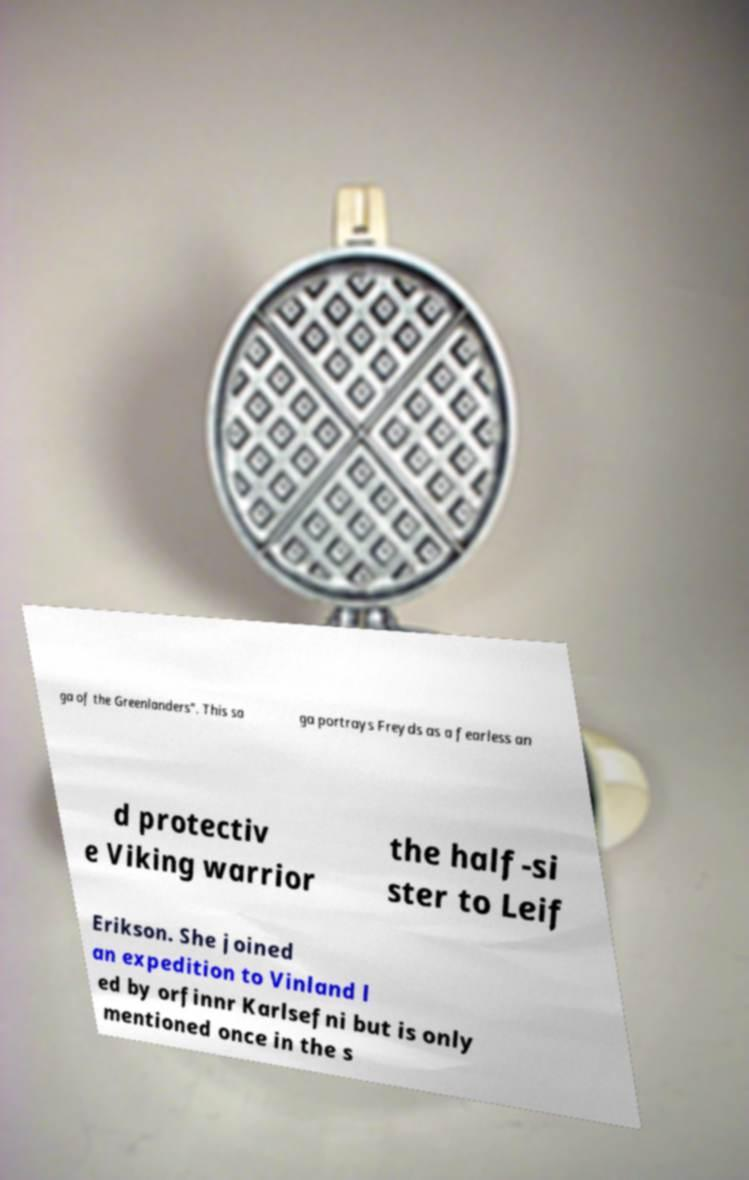What messages or text are displayed in this image? I need them in a readable, typed format. ga of the Greenlanders". This sa ga portrays Freyds as a fearless an d protectiv e Viking warrior the half-si ster to Leif Erikson. She joined an expedition to Vinland l ed by orfinnr Karlsefni but is only mentioned once in the s 